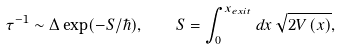<formula> <loc_0><loc_0><loc_500><loc_500>\tau ^ { - 1 } \sim \Delta \exp ( - S / \hbar { ) } , \quad S = \int _ { 0 } ^ { x _ { e x i t } } d x \, \sqrt { 2 V \left ( x \right ) } ,</formula> 